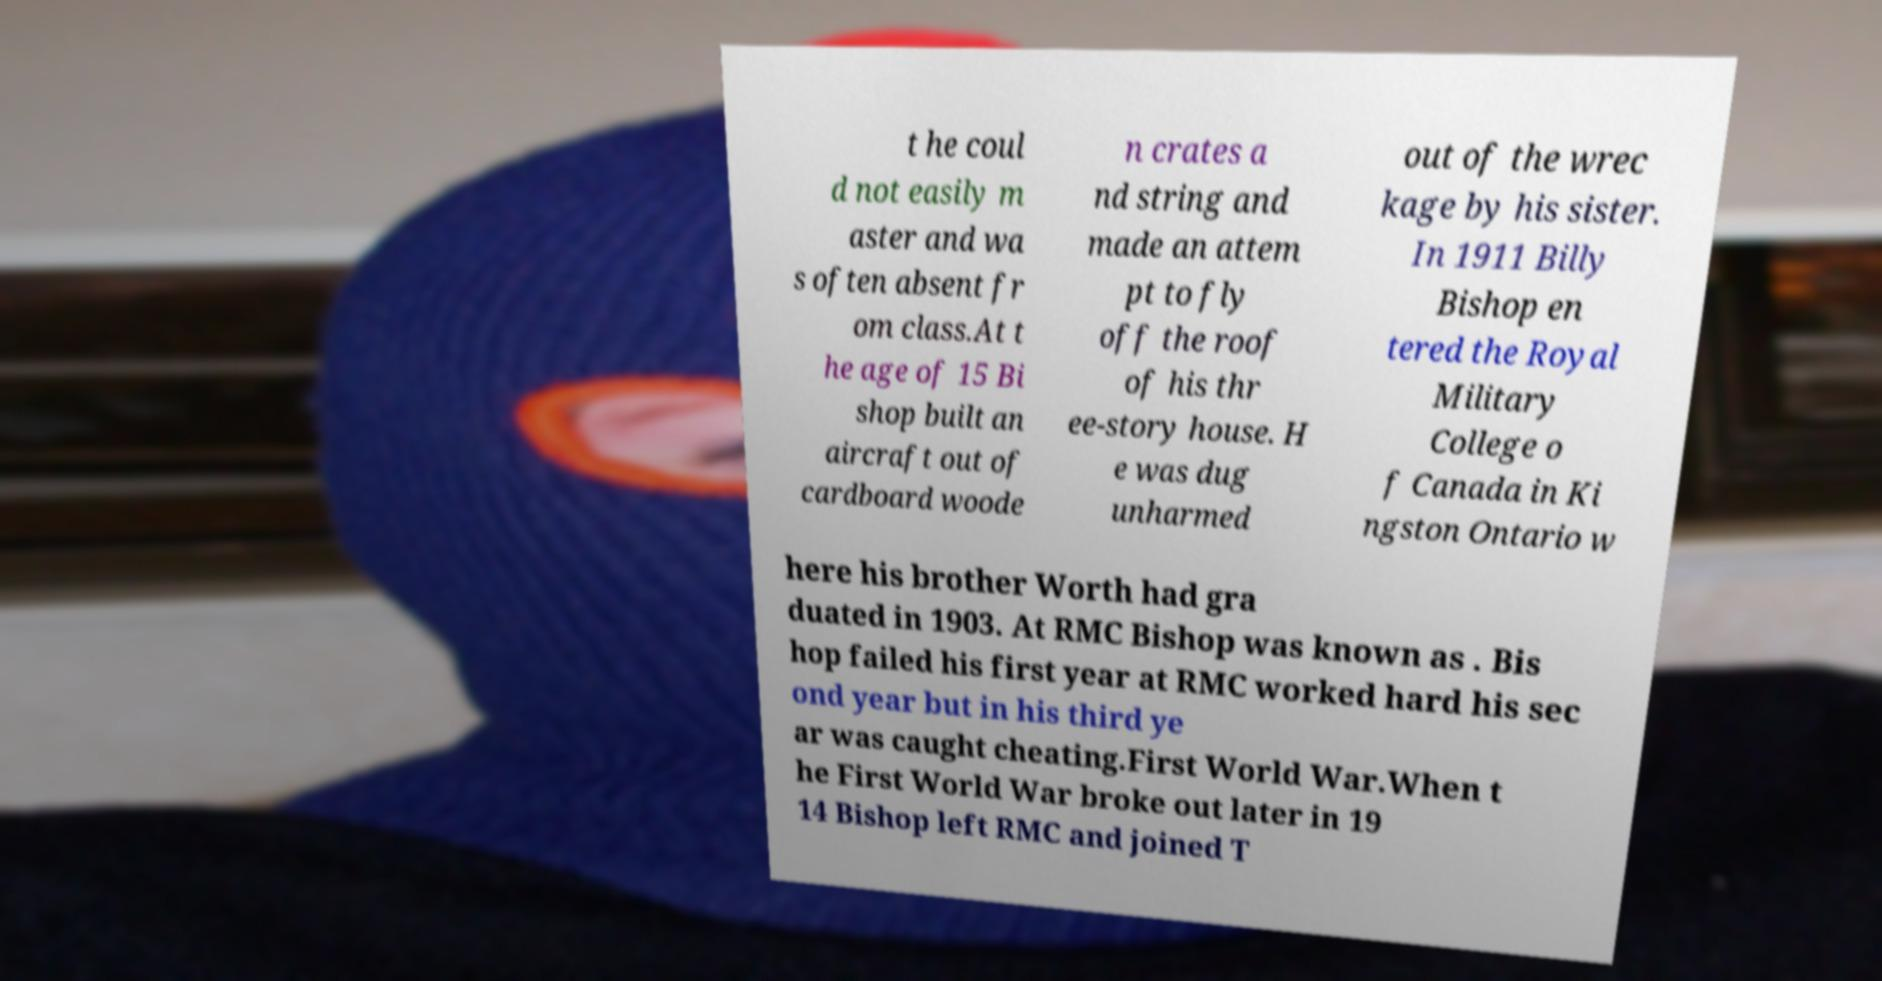Please identify and transcribe the text found in this image. t he coul d not easily m aster and wa s often absent fr om class.At t he age of 15 Bi shop built an aircraft out of cardboard woode n crates a nd string and made an attem pt to fly off the roof of his thr ee-story house. H e was dug unharmed out of the wrec kage by his sister. In 1911 Billy Bishop en tered the Royal Military College o f Canada in Ki ngston Ontario w here his brother Worth had gra duated in 1903. At RMC Bishop was known as . Bis hop failed his first year at RMC worked hard his sec ond year but in his third ye ar was caught cheating.First World War.When t he First World War broke out later in 19 14 Bishop left RMC and joined T 